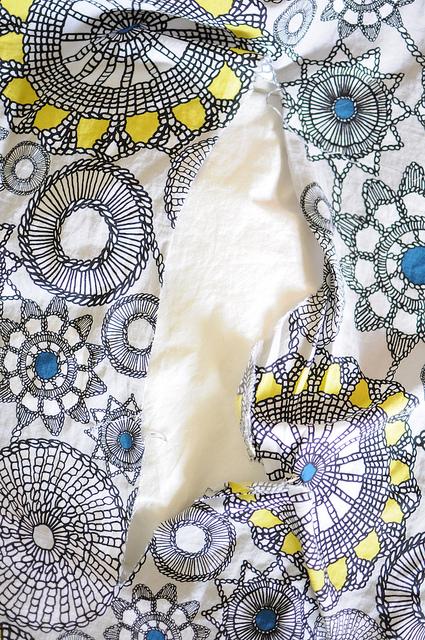Does the cloth have a picture of living things?
Write a very short answer. No. Is the white substance in the center brittle?
Write a very short answer. Yes. What colors can you see on the cloth?
Give a very brief answer. Yellow and blue. 